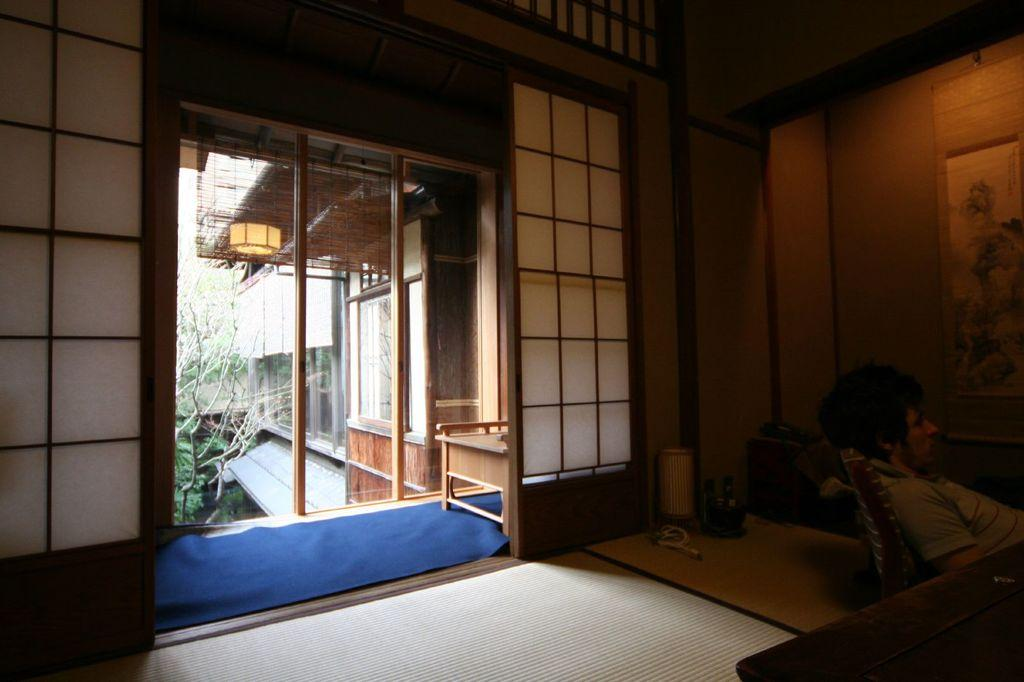Where is the setting of the image? The image is inside a house. What can be seen in the middle of the image? There is an entrance in the middle of the image. Can you describe the person in the image? There is a person sitting on a chair on the right side of the image. What is the caption of the image? There is no caption present in the image. 